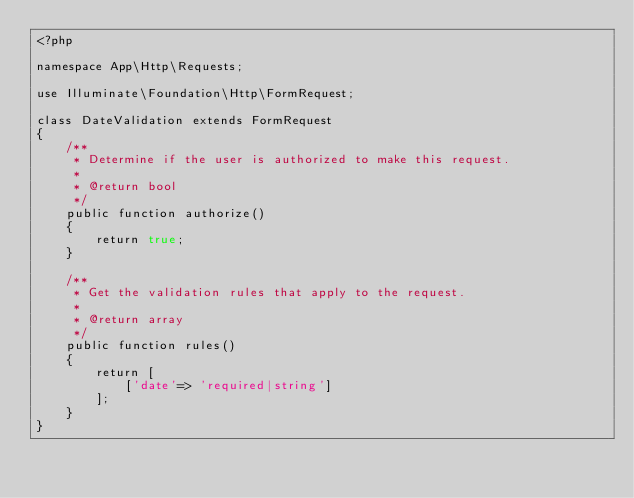Convert code to text. <code><loc_0><loc_0><loc_500><loc_500><_PHP_><?php

namespace App\Http\Requests;

use Illuminate\Foundation\Http\FormRequest;

class DateValidation extends FormRequest
{
    /**
     * Determine if the user is authorized to make this request.
     *
     * @return bool
     */
    public function authorize()
    {
        return true;
    }

    /**
     * Get the validation rules that apply to the request.
     *
     * @return array
     */
    public function rules()
    {
        return [
            ['date'=> 'required|string']
        ];
    }
}
</code> 